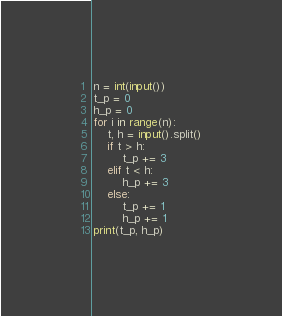Convert code to text. <code><loc_0><loc_0><loc_500><loc_500><_Python_>n = int(input())
t_p = 0
h_p = 0
for i in range(n):
    t, h = input().split()
    if t > h:
        t_p += 3
    elif t < h:
        h_p += 3
    else:
        t_p += 1
        h_p += 1
print(t_p, h_p)

</code> 